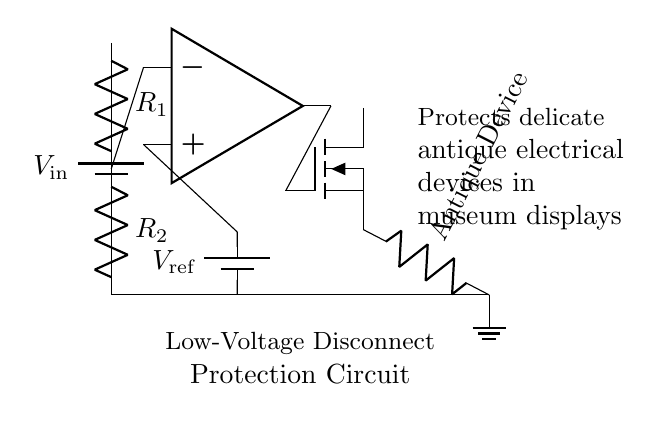What type of devices does this circuit protect? The circuit is designed to protect delicate antique electrical devices, as stated in the labels within the diagram.
Answer: Antique devices What is the function of the MOSFET in this circuit? The MOSFET acts as a switch that disconnects the load (antique device) based on the output from the comparator, which regulates power based on the voltage levels.
Answer: Switch What is the reference voltage value according to the diagram? The diagram shows a reference voltage represented as V_ref, but does not provide a specific numerical value; it is a symbol for the reference voltage used.
Answer: V_ref How many resistors are present in the voltage divider? The circuit includes two resistors labeled as R_1 and R_2, forming a voltage divider that influences the input to the comparator.
Answer: Two What does the op-amp compare in this circuit? The op-amp compares the voltage across the voltage divider (R_1 and R_2) at its negative input to the reference voltage at its positive input to determine whether to activate or deactivate the MOSFET.
Answer: Voltage levels What is the output condition of the circuit if the input voltage is lower than the reference voltage? If the input voltage is lower than the reference voltage, the op-amp output will indicate that the MOSFET should turn off, resulting in the disconnection of the antique device from power to protect it from low voltage damage.
Answer: Disconnect What is the overall purpose of this protection circuit? The overall purpose of the circuit is to provide low-voltage disconnect protection, ensuring that delicate antique devices in museum displays are not adversely affected by unsafe voltage levels.
Answer: Protection 